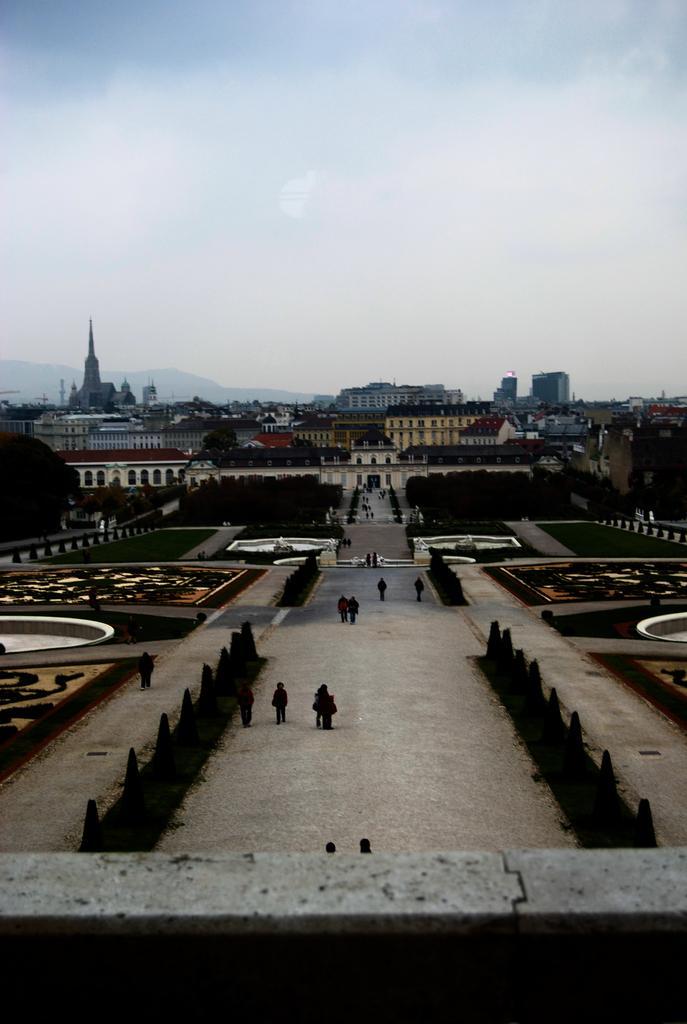Can you describe this image briefly? In this image, there are a few buildings, trees, people, plants. We can see the ground with some grass and objects. We can also see the sky. 